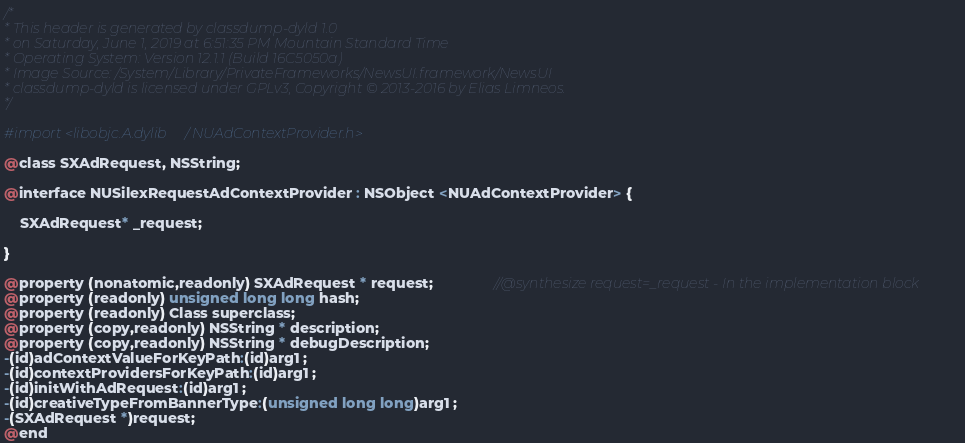Convert code to text. <code><loc_0><loc_0><loc_500><loc_500><_C_>/*
* This header is generated by classdump-dyld 1.0
* on Saturday, June 1, 2019 at 6:51:35 PM Mountain Standard Time
* Operating System: Version 12.1.1 (Build 16C5050a)
* Image Source: /System/Library/PrivateFrameworks/NewsUI.framework/NewsUI
* classdump-dyld is licensed under GPLv3, Copyright © 2013-2016 by Elias Limneos.
*/

#import <libobjc.A.dylib/NUAdContextProvider.h>

@class SXAdRequest, NSString;

@interface NUSilexRequestAdContextProvider : NSObject <NUAdContextProvider> {

	SXAdRequest* _request;

}

@property (nonatomic,readonly) SXAdRequest * request;               //@synthesize request=_request - In the implementation block
@property (readonly) unsigned long long hash; 
@property (readonly) Class superclass; 
@property (copy,readonly) NSString * description; 
@property (copy,readonly) NSString * debugDescription; 
-(id)adContextValueForKeyPath:(id)arg1 ;
-(id)contextProvidersForKeyPath:(id)arg1 ;
-(id)initWithAdRequest:(id)arg1 ;
-(id)creativeTypeFromBannerType:(unsigned long long)arg1 ;
-(SXAdRequest *)request;
@end

</code> 